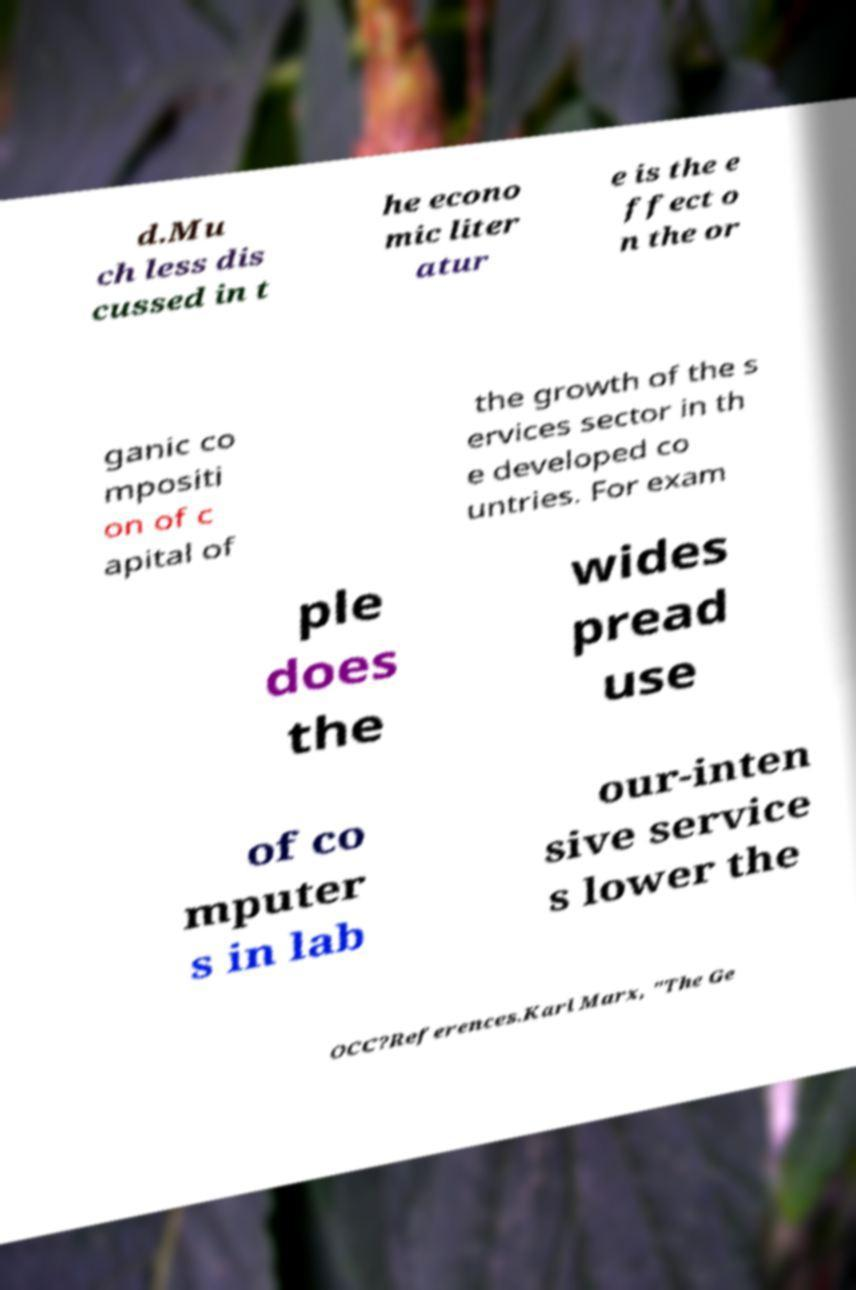What messages or text are displayed in this image? I need them in a readable, typed format. d.Mu ch less dis cussed in t he econo mic liter atur e is the e ffect o n the or ganic co mpositi on of c apital of the growth of the s ervices sector in th e developed co untries. For exam ple does the wides pread use of co mputer s in lab our-inten sive service s lower the OCC?References.Karl Marx, "The Ge 